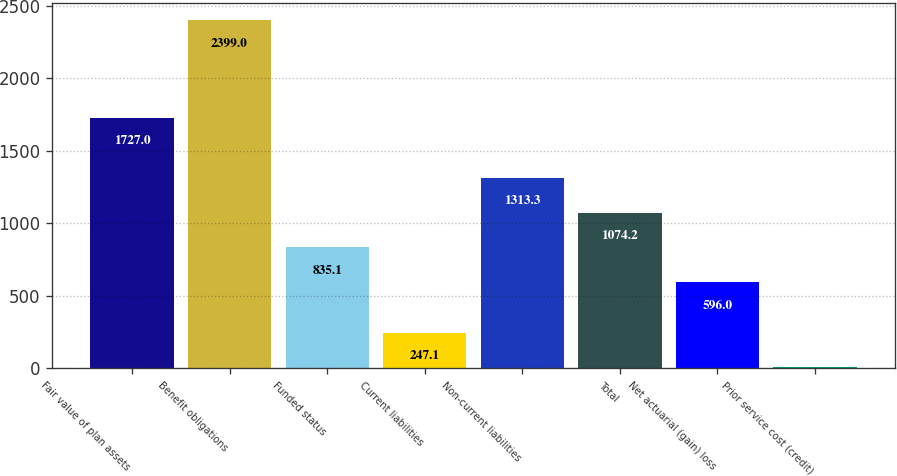<chart> <loc_0><loc_0><loc_500><loc_500><bar_chart><fcel>Fair value of plan assets<fcel>Benefit obligations<fcel>Funded status<fcel>Current liabilities<fcel>Non-current liabilities<fcel>Total<fcel>Net actuarial (gain) loss<fcel>Prior service cost (credit)<nl><fcel>1727<fcel>2399<fcel>835.1<fcel>247.1<fcel>1313.3<fcel>1074.2<fcel>596<fcel>8<nl></chart> 